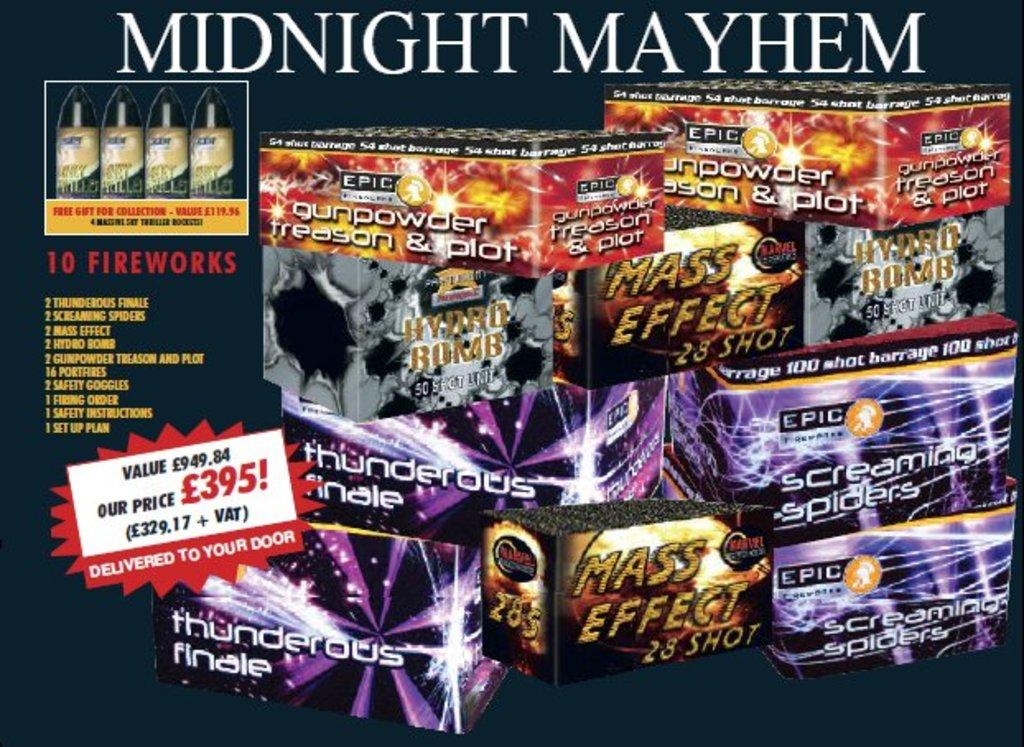<image>
Render a clear and concise summary of the photo. a midnight mayhem text over some gaming items 